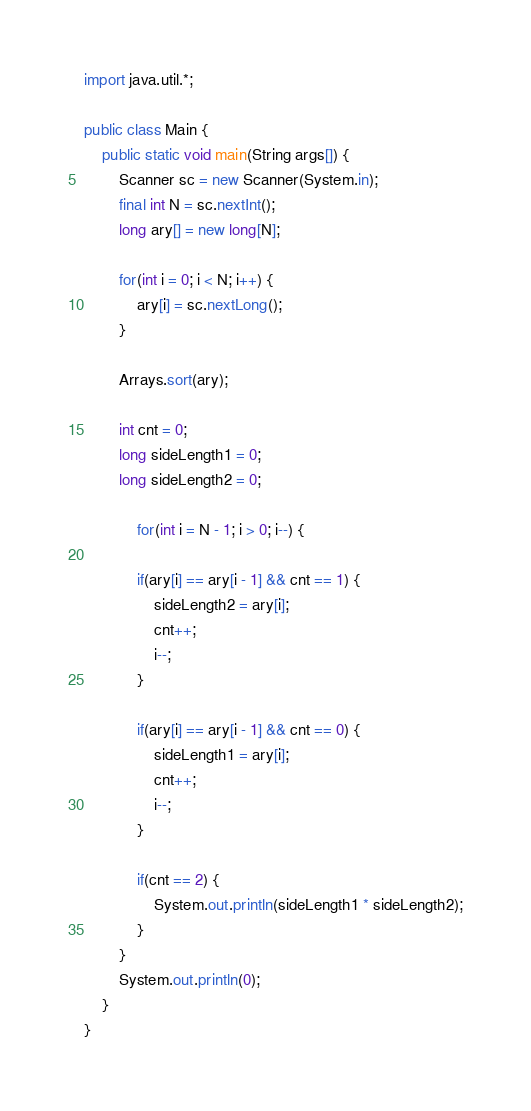<code> <loc_0><loc_0><loc_500><loc_500><_Java_>import java.util.*;

public class Main {
	public static void main(String args[]) {
		Scanner sc = new Scanner(System.in);
		final int N = sc.nextInt();
		long ary[] = new long[N];
		
		for(int i = 0; i < N; i++) {
			ary[i] = sc.nextLong();
		}
		
		Arrays.sort(ary);
		
		int cnt = 0;
		long sideLength1 = 0;
		long sideLength2 = 0;
		
			for(int i = N - 1; i > 0; i--) {
			
			if(ary[i] == ary[i - 1] && cnt == 1) {
				sideLength2 = ary[i];
				cnt++;
				i--;
			}
			
			if(ary[i] == ary[i - 1] && cnt == 0) {
				sideLength1 = ary[i];
				cnt++;
				i--;
			}
			
			if(cnt == 2) {
				System.out.println(sideLength1 * sideLength2);
			}
		}
		System.out.println(0);
	}
}
</code> 